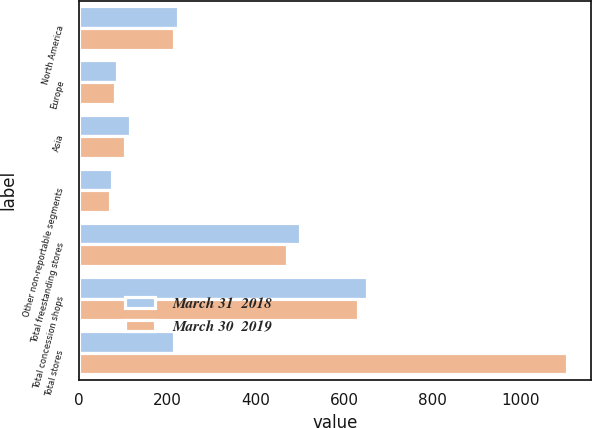Convert chart to OTSL. <chart><loc_0><loc_0><loc_500><loc_500><stacked_bar_chart><ecel><fcel>North America<fcel>Europe<fcel>Asia<fcel>Other non-reportable segments<fcel>Total freestanding stores<fcel>Total concession shops<fcel>Total stores<nl><fcel>March 31  2018<fcel>224<fcel>87<fcel>115<fcel>75<fcel>501<fcel>653<fcel>215<nl><fcel>March 30  2019<fcel>215<fcel>81<fcel>105<fcel>71<fcel>472<fcel>632<fcel>1104<nl></chart> 